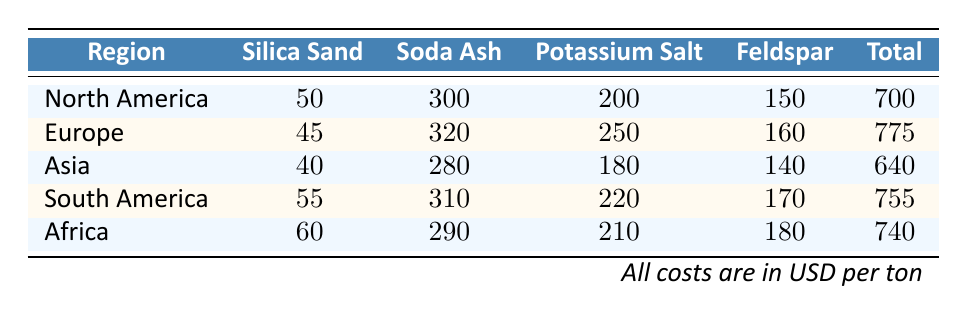What is the cost of silica sand per ton in North America? The table shows the cost for silica sand specifically listed for North America, which is 50.
Answer: 50 Which region has the highest total cost per ton for raw materials? I compare the total costs of each region listed in the table: North America (700), Europe (775), Asia (640), South America (755), and Africa (740). The highest is Europe at 775.
Answer: Europe What is the difference in the cost of soda ash per ton between Asia and South America? The cost of soda ash in Asia is 280 and in South America, it is 310. I calculate the difference as 310 - 280 = 30.
Answer: 30 Is the cost of potassium salt per ton in Africa greater than that in North America? The costs are 210 for Africa and 200 for North America. Since 210 is greater than 200, the answer is yes.
Answer: Yes What is the average total cost per ton of the raw materials across all regions? I sum the total costs: 700 + 775 + 640 + 755 + 740 = 3910. There are 5 regions, so I divide to find the average: 3910 / 5 = 782.
Answer: 782 Which region has the lowest cost for feldspar per ton? The feldspar costs per region are North America (150), Europe (160), Asia (140), South America (170), and Africa (180). The lowest cost is 140 in Asia.
Answer: Asia What is the total cost of raw materials in North America compared to Asia? The total costs are 700 for North America and 640 for Asia. The comparison shows that North America has a higher total cost by 60 (700 - 640).
Answer: No Is the cost of silica sand in South America less than that in Europe? Silica sand costs are 55 in South America and 45 in Europe. Since 55 is greater than 45, the answer is no.
Answer: No 